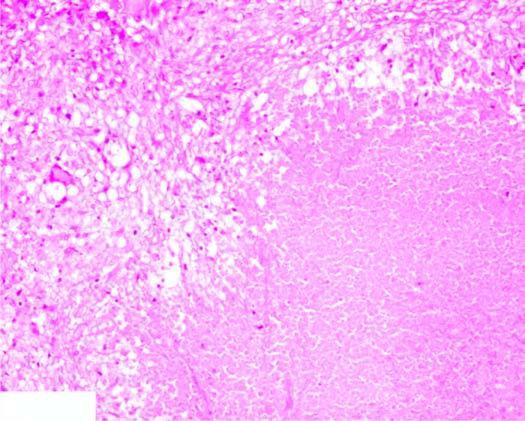s there eosinophilic, amorphous, granular material, while the periphery shows granulomatous inflammation?
Answer the question using a single word or phrase. Yes 